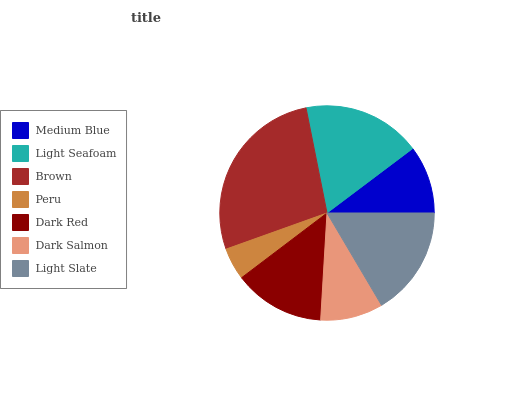Is Peru the minimum?
Answer yes or no. Yes. Is Brown the maximum?
Answer yes or no. Yes. Is Light Seafoam the minimum?
Answer yes or no. No. Is Light Seafoam the maximum?
Answer yes or no. No. Is Light Seafoam greater than Medium Blue?
Answer yes or no. Yes. Is Medium Blue less than Light Seafoam?
Answer yes or no. Yes. Is Medium Blue greater than Light Seafoam?
Answer yes or no. No. Is Light Seafoam less than Medium Blue?
Answer yes or no. No. Is Dark Red the high median?
Answer yes or no. Yes. Is Dark Red the low median?
Answer yes or no. Yes. Is Light Slate the high median?
Answer yes or no. No. Is Medium Blue the low median?
Answer yes or no. No. 